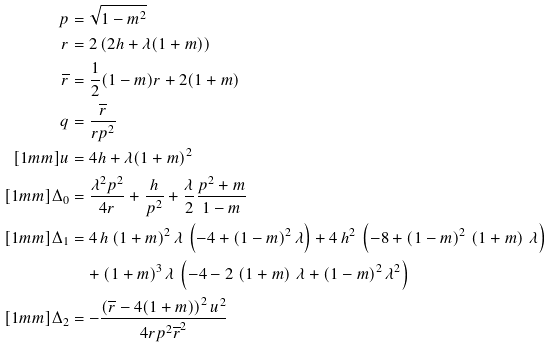Convert formula to latex. <formula><loc_0><loc_0><loc_500><loc_500>p & = \sqrt { 1 - m ^ { 2 } } \\ r & = 2 \left ( 2 h + \lambda ( 1 + m ) \right ) \\ \overline { r } & = \frac { 1 } { 2 } ( 1 - m ) r + 2 ( 1 + m ) \\ q & = \frac { \overline { r } } { r p ^ { 2 } } \\ [ 1 m m ] u & = 4 h + \lambda ( 1 + m ) ^ { 2 } \\ [ 1 m m ] \Delta _ { 0 } & = \frac { \lambda ^ { 2 } p ^ { 2 } } { 4 r } + \frac { h } { p ^ { 2 } } + \frac { \lambda } { 2 } \frac { p ^ { 2 } + m } { 1 - m } \\ [ 1 m m ] \Delta _ { 1 } & = 4 \, h \, { \left ( 1 + m \right ) } ^ { 2 } \, \lambda \, \left ( - 4 + { \left ( 1 - m \right ) } ^ { 2 } \, \lambda \right ) + 4 \, h ^ { 2 } \, \left ( - 8 + { \left ( 1 - m \right ) } ^ { 2 } \, \left ( 1 + m \right ) \, \lambda \right ) \\ & \quad + { \left ( 1 + m \right ) } ^ { 3 } \, \lambda \, \left ( - 4 - 2 \, \left ( 1 + m \right ) \, \lambda + { \left ( 1 - m \right ) } ^ { 2 } \, { \lambda } ^ { 2 } \right ) \\ [ 1 m m ] \Delta _ { 2 } & = - \frac { \left ( \overline { r } - 4 ( 1 + m ) \right ) ^ { 2 } u ^ { 2 } } { 4 r p ^ { 2 } \overline { r } ^ { 2 } }</formula> 